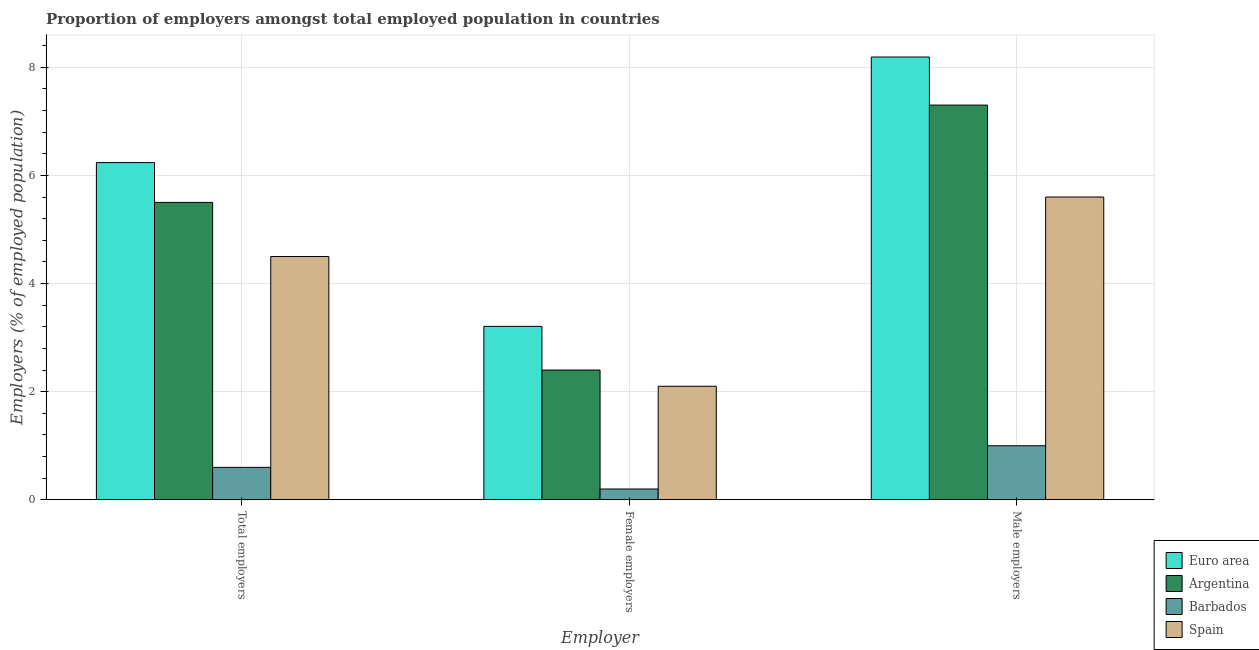How many groups of bars are there?
Your response must be concise. 3. Are the number of bars on each tick of the X-axis equal?
Provide a succinct answer. Yes. How many bars are there on the 3rd tick from the left?
Your answer should be compact. 4. How many bars are there on the 3rd tick from the right?
Provide a short and direct response. 4. What is the label of the 3rd group of bars from the left?
Make the answer very short. Male employers. What is the percentage of male employers in Barbados?
Offer a very short reply. 1. Across all countries, what is the maximum percentage of total employers?
Your answer should be very brief. 6.24. Across all countries, what is the minimum percentage of total employers?
Your answer should be compact. 0.6. In which country was the percentage of total employers maximum?
Offer a very short reply. Euro area. In which country was the percentage of male employers minimum?
Offer a very short reply. Barbados. What is the total percentage of female employers in the graph?
Provide a succinct answer. 7.91. What is the difference between the percentage of female employers in Euro area and that in Spain?
Your response must be concise. 1.11. What is the difference between the percentage of female employers in Argentina and the percentage of male employers in Barbados?
Offer a very short reply. 1.4. What is the average percentage of female employers per country?
Keep it short and to the point. 1.98. What is the difference between the percentage of total employers and percentage of male employers in Euro area?
Make the answer very short. -1.95. In how many countries, is the percentage of male employers greater than 4.8 %?
Make the answer very short. 3. What is the ratio of the percentage of male employers in Euro area to that in Argentina?
Your answer should be very brief. 1.12. Is the difference between the percentage of total employers in Spain and Euro area greater than the difference between the percentage of female employers in Spain and Euro area?
Offer a terse response. No. What is the difference between the highest and the second highest percentage of female employers?
Your answer should be compact. 0.81. What is the difference between the highest and the lowest percentage of total employers?
Your answer should be compact. 5.64. In how many countries, is the percentage of female employers greater than the average percentage of female employers taken over all countries?
Offer a terse response. 3. What does the 2nd bar from the right in Male employers represents?
Your answer should be compact. Barbados. Is it the case that in every country, the sum of the percentage of total employers and percentage of female employers is greater than the percentage of male employers?
Provide a short and direct response. No. Are all the bars in the graph horizontal?
Your answer should be very brief. No. What is the difference between two consecutive major ticks on the Y-axis?
Offer a very short reply. 2. Does the graph contain any zero values?
Offer a terse response. No. Where does the legend appear in the graph?
Give a very brief answer. Bottom right. How many legend labels are there?
Make the answer very short. 4. How are the legend labels stacked?
Give a very brief answer. Vertical. What is the title of the graph?
Provide a succinct answer. Proportion of employers amongst total employed population in countries. What is the label or title of the X-axis?
Ensure brevity in your answer.  Employer. What is the label or title of the Y-axis?
Offer a very short reply. Employers (% of employed population). What is the Employers (% of employed population) of Euro area in Total employers?
Your response must be concise. 6.24. What is the Employers (% of employed population) in Barbados in Total employers?
Make the answer very short. 0.6. What is the Employers (% of employed population) of Euro area in Female employers?
Keep it short and to the point. 3.21. What is the Employers (% of employed population) in Argentina in Female employers?
Provide a short and direct response. 2.4. What is the Employers (% of employed population) of Barbados in Female employers?
Keep it short and to the point. 0.2. What is the Employers (% of employed population) of Spain in Female employers?
Provide a short and direct response. 2.1. What is the Employers (% of employed population) of Euro area in Male employers?
Your answer should be very brief. 8.19. What is the Employers (% of employed population) in Argentina in Male employers?
Your answer should be compact. 7.3. What is the Employers (% of employed population) in Barbados in Male employers?
Ensure brevity in your answer.  1. What is the Employers (% of employed population) in Spain in Male employers?
Your response must be concise. 5.6. Across all Employer, what is the maximum Employers (% of employed population) of Euro area?
Your answer should be compact. 8.19. Across all Employer, what is the maximum Employers (% of employed population) in Argentina?
Your answer should be compact. 7.3. Across all Employer, what is the maximum Employers (% of employed population) of Spain?
Offer a very short reply. 5.6. Across all Employer, what is the minimum Employers (% of employed population) of Euro area?
Provide a short and direct response. 3.21. Across all Employer, what is the minimum Employers (% of employed population) in Argentina?
Keep it short and to the point. 2.4. Across all Employer, what is the minimum Employers (% of employed population) of Barbados?
Provide a short and direct response. 0.2. Across all Employer, what is the minimum Employers (% of employed population) in Spain?
Offer a very short reply. 2.1. What is the total Employers (% of employed population) of Euro area in the graph?
Make the answer very short. 17.63. What is the total Employers (% of employed population) in Argentina in the graph?
Ensure brevity in your answer.  15.2. What is the total Employers (% of employed population) in Barbados in the graph?
Your answer should be very brief. 1.8. What is the total Employers (% of employed population) of Spain in the graph?
Make the answer very short. 12.2. What is the difference between the Employers (% of employed population) in Euro area in Total employers and that in Female employers?
Give a very brief answer. 3.03. What is the difference between the Employers (% of employed population) in Argentina in Total employers and that in Female employers?
Make the answer very short. 3.1. What is the difference between the Employers (% of employed population) of Barbados in Total employers and that in Female employers?
Provide a short and direct response. 0.4. What is the difference between the Employers (% of employed population) in Euro area in Total employers and that in Male employers?
Your answer should be very brief. -1.95. What is the difference between the Employers (% of employed population) in Spain in Total employers and that in Male employers?
Keep it short and to the point. -1.1. What is the difference between the Employers (% of employed population) in Euro area in Female employers and that in Male employers?
Offer a terse response. -4.98. What is the difference between the Employers (% of employed population) of Euro area in Total employers and the Employers (% of employed population) of Argentina in Female employers?
Offer a terse response. 3.84. What is the difference between the Employers (% of employed population) in Euro area in Total employers and the Employers (% of employed population) in Barbados in Female employers?
Your response must be concise. 6.04. What is the difference between the Employers (% of employed population) of Euro area in Total employers and the Employers (% of employed population) of Spain in Female employers?
Provide a short and direct response. 4.14. What is the difference between the Employers (% of employed population) in Argentina in Total employers and the Employers (% of employed population) in Barbados in Female employers?
Keep it short and to the point. 5.3. What is the difference between the Employers (% of employed population) in Barbados in Total employers and the Employers (% of employed population) in Spain in Female employers?
Provide a succinct answer. -1.5. What is the difference between the Employers (% of employed population) in Euro area in Total employers and the Employers (% of employed population) in Argentina in Male employers?
Provide a short and direct response. -1.06. What is the difference between the Employers (% of employed population) in Euro area in Total employers and the Employers (% of employed population) in Barbados in Male employers?
Provide a short and direct response. 5.24. What is the difference between the Employers (% of employed population) in Euro area in Total employers and the Employers (% of employed population) in Spain in Male employers?
Provide a short and direct response. 0.64. What is the difference between the Employers (% of employed population) in Argentina in Total employers and the Employers (% of employed population) in Spain in Male employers?
Your answer should be very brief. -0.1. What is the difference between the Employers (% of employed population) of Barbados in Total employers and the Employers (% of employed population) of Spain in Male employers?
Offer a very short reply. -5. What is the difference between the Employers (% of employed population) in Euro area in Female employers and the Employers (% of employed population) in Argentina in Male employers?
Keep it short and to the point. -4.09. What is the difference between the Employers (% of employed population) of Euro area in Female employers and the Employers (% of employed population) of Barbados in Male employers?
Your answer should be compact. 2.21. What is the difference between the Employers (% of employed population) in Euro area in Female employers and the Employers (% of employed population) in Spain in Male employers?
Provide a short and direct response. -2.39. What is the average Employers (% of employed population) of Euro area per Employer?
Provide a succinct answer. 5.88. What is the average Employers (% of employed population) of Argentina per Employer?
Your answer should be very brief. 5.07. What is the average Employers (% of employed population) in Barbados per Employer?
Offer a very short reply. 0.6. What is the average Employers (% of employed population) of Spain per Employer?
Provide a short and direct response. 4.07. What is the difference between the Employers (% of employed population) in Euro area and Employers (% of employed population) in Argentina in Total employers?
Offer a very short reply. 0.74. What is the difference between the Employers (% of employed population) of Euro area and Employers (% of employed population) of Barbados in Total employers?
Provide a succinct answer. 5.64. What is the difference between the Employers (% of employed population) in Euro area and Employers (% of employed population) in Spain in Total employers?
Your answer should be compact. 1.74. What is the difference between the Employers (% of employed population) in Euro area and Employers (% of employed population) in Argentina in Female employers?
Your answer should be compact. 0.81. What is the difference between the Employers (% of employed population) in Euro area and Employers (% of employed population) in Barbados in Female employers?
Your answer should be very brief. 3.01. What is the difference between the Employers (% of employed population) in Euro area and Employers (% of employed population) in Spain in Female employers?
Offer a very short reply. 1.11. What is the difference between the Employers (% of employed population) of Argentina and Employers (% of employed population) of Barbados in Female employers?
Your response must be concise. 2.2. What is the difference between the Employers (% of employed population) of Euro area and Employers (% of employed population) of Argentina in Male employers?
Your answer should be compact. 0.89. What is the difference between the Employers (% of employed population) in Euro area and Employers (% of employed population) in Barbados in Male employers?
Provide a succinct answer. 7.19. What is the difference between the Employers (% of employed population) in Euro area and Employers (% of employed population) in Spain in Male employers?
Offer a very short reply. 2.59. What is the difference between the Employers (% of employed population) in Argentina and Employers (% of employed population) in Barbados in Male employers?
Ensure brevity in your answer.  6.3. What is the difference between the Employers (% of employed population) in Argentina and Employers (% of employed population) in Spain in Male employers?
Provide a short and direct response. 1.7. What is the difference between the Employers (% of employed population) in Barbados and Employers (% of employed population) in Spain in Male employers?
Your answer should be compact. -4.6. What is the ratio of the Employers (% of employed population) in Euro area in Total employers to that in Female employers?
Your answer should be very brief. 1.94. What is the ratio of the Employers (% of employed population) in Argentina in Total employers to that in Female employers?
Provide a succinct answer. 2.29. What is the ratio of the Employers (% of employed population) in Barbados in Total employers to that in Female employers?
Keep it short and to the point. 3. What is the ratio of the Employers (% of employed population) in Spain in Total employers to that in Female employers?
Make the answer very short. 2.14. What is the ratio of the Employers (% of employed population) in Euro area in Total employers to that in Male employers?
Keep it short and to the point. 0.76. What is the ratio of the Employers (% of employed population) in Argentina in Total employers to that in Male employers?
Your answer should be compact. 0.75. What is the ratio of the Employers (% of employed population) in Barbados in Total employers to that in Male employers?
Offer a very short reply. 0.6. What is the ratio of the Employers (% of employed population) in Spain in Total employers to that in Male employers?
Your answer should be very brief. 0.8. What is the ratio of the Employers (% of employed population) of Euro area in Female employers to that in Male employers?
Keep it short and to the point. 0.39. What is the ratio of the Employers (% of employed population) of Argentina in Female employers to that in Male employers?
Ensure brevity in your answer.  0.33. What is the ratio of the Employers (% of employed population) in Spain in Female employers to that in Male employers?
Your answer should be very brief. 0.38. What is the difference between the highest and the second highest Employers (% of employed population) of Euro area?
Make the answer very short. 1.95. What is the difference between the highest and the second highest Employers (% of employed population) in Barbados?
Provide a short and direct response. 0.4. What is the difference between the highest and the second highest Employers (% of employed population) of Spain?
Offer a terse response. 1.1. What is the difference between the highest and the lowest Employers (% of employed population) of Euro area?
Provide a short and direct response. 4.98. What is the difference between the highest and the lowest Employers (% of employed population) in Argentina?
Keep it short and to the point. 4.9. What is the difference between the highest and the lowest Employers (% of employed population) of Spain?
Give a very brief answer. 3.5. 